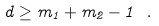Convert formula to latex. <formula><loc_0><loc_0><loc_500><loc_500>d \geq m _ { 1 } + m _ { 2 } - 1 \ .</formula> 